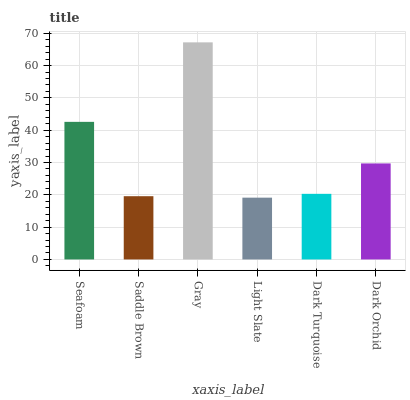Is Light Slate the minimum?
Answer yes or no. Yes. Is Gray the maximum?
Answer yes or no. Yes. Is Saddle Brown the minimum?
Answer yes or no. No. Is Saddle Brown the maximum?
Answer yes or no. No. Is Seafoam greater than Saddle Brown?
Answer yes or no. Yes. Is Saddle Brown less than Seafoam?
Answer yes or no. Yes. Is Saddle Brown greater than Seafoam?
Answer yes or no. No. Is Seafoam less than Saddle Brown?
Answer yes or no. No. Is Dark Orchid the high median?
Answer yes or no. Yes. Is Dark Turquoise the low median?
Answer yes or no. Yes. Is Gray the high median?
Answer yes or no. No. Is Dark Orchid the low median?
Answer yes or no. No. 